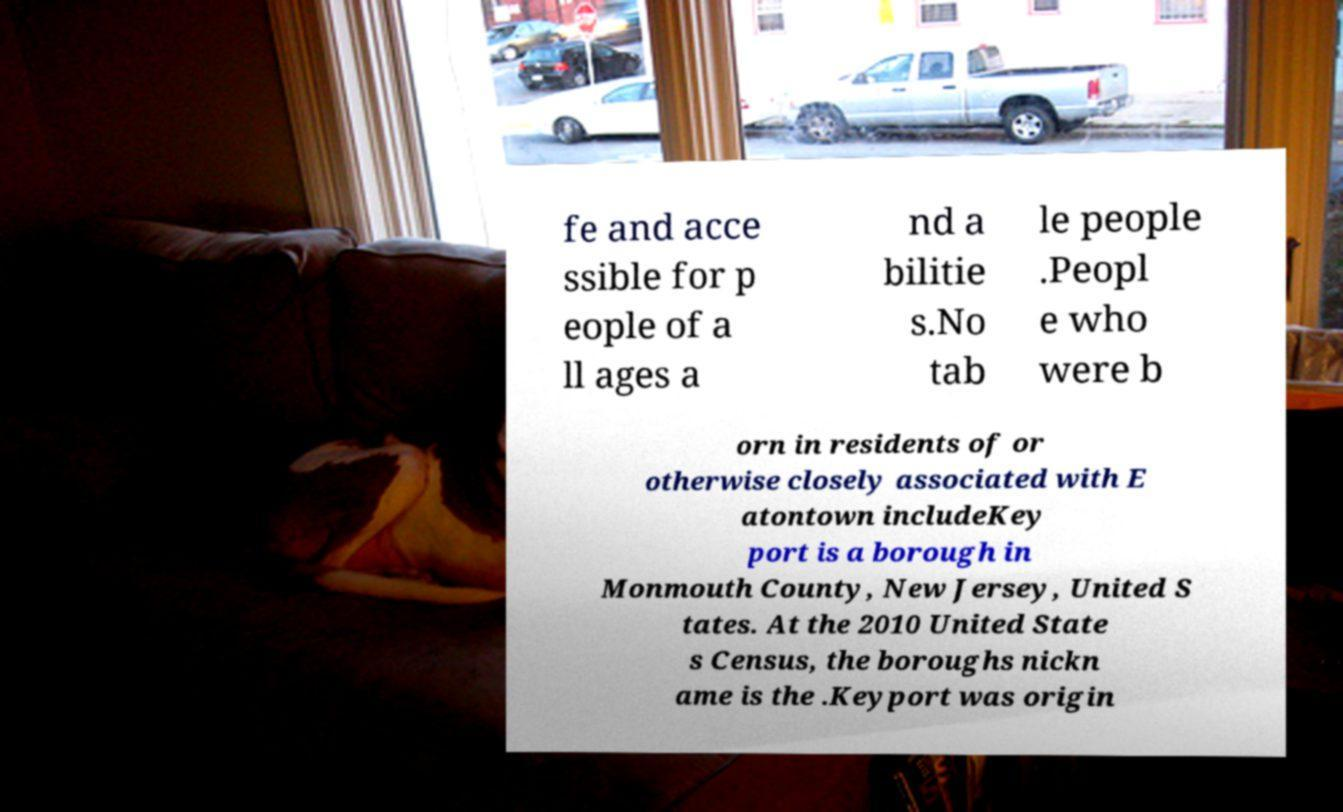Please identify and transcribe the text found in this image. fe and acce ssible for p eople of a ll ages a nd a bilitie s.No tab le people .Peopl e who were b orn in residents of or otherwise closely associated with E atontown includeKey port is a borough in Monmouth County, New Jersey, United S tates. At the 2010 United State s Census, the boroughs nickn ame is the .Keyport was origin 